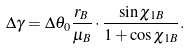Convert formula to latex. <formula><loc_0><loc_0><loc_500><loc_500>\Delta \gamma = \Delta \theta _ { 0 } \frac { r _ { B } } { \mu _ { B } } \cdot \frac { \sin \chi _ { 1 B } } { 1 + \cos \chi _ { 1 B } } .</formula> 